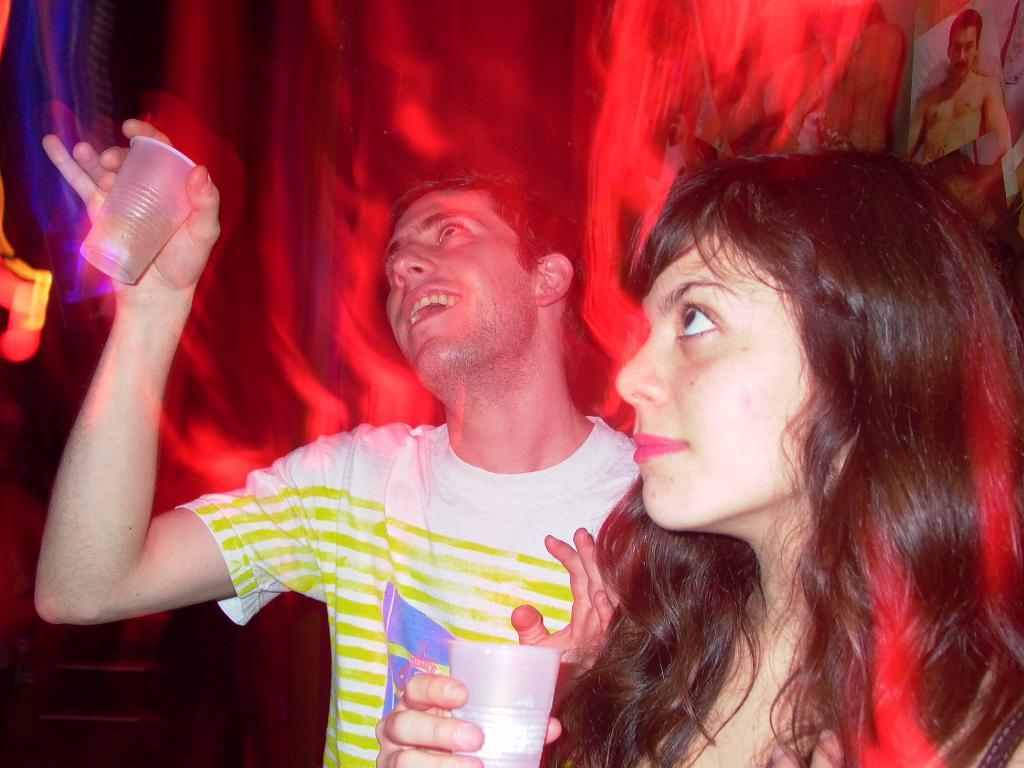Who or what is present in the image? There are people in the image. What are the people holding in their hands? The people are holding glasses in their hands. Can you describe any other elements in the image? There is a photo in the top right corner of the image. What type of liquid is being poured from the glasses in the image? There is no liquid being poured in the image; the people are simply holding glasses. 